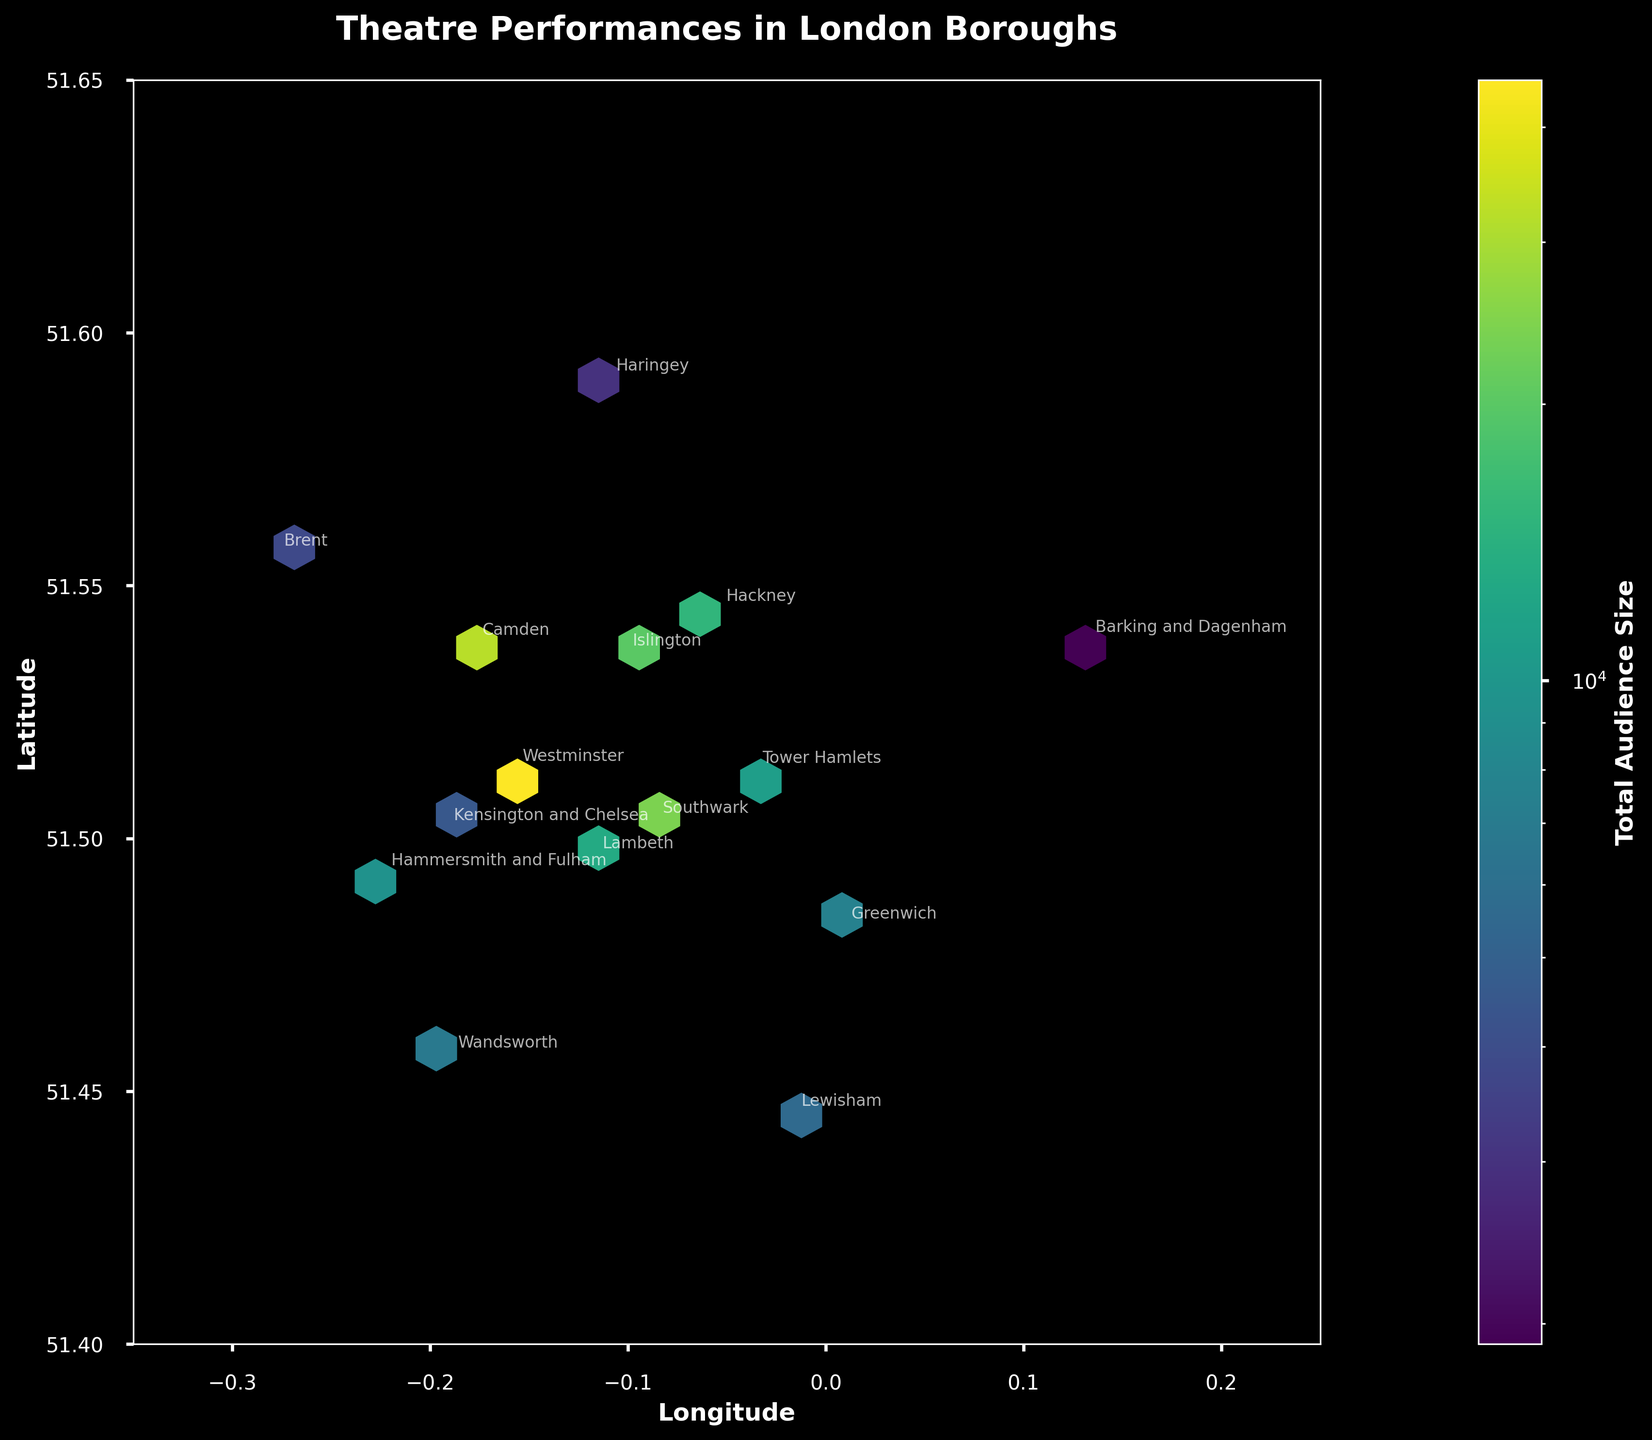how many total audience sizes are depicted on the color bar? The color bar indicates the summed audience sizes that correspond to the color intensity in the hexbin plot. It aggregates the total audience size for performances in specific geographic locations by different shades of color in a logarithmic scale.
Answer: Sum of audience sizes What's the total audience size for Lambeth? Locate Lambeth on the plot and identify its coordinates. Check the color intensity in and around that location on the plot, which reflects the audience size aggregated over that area.
Answer: 13,000 Which borough has the highest concentration of audience sizes? Find the hexbin on the plot with the highest color intensity. The borough labels will help identify which borough it is.
Answer: Westminster Between Hackney and Camden, which borough has more performances? Compare the positions of Hackney and Camden on the plot. Notice the size and color intensity of the hexagon bins in each of these locations to determine the number of performances.
Answer: Camden How does the audience size of Southwark compare to that of Islington? Locate Southwark and Islington on the plot. Compare the color intensities in those areas, as higher intensities indicate larger audience sizes.
Answer: Southwark has a larger audience size What is the smallest total audience size depicted in any hexbin on the plot? Identify the color bar's lower end to determine the smallest total audience size shown on the plot. Then find the hexbin that matches this color intensity.
Answer: 1 Do boroughs closer to central London tend to have higher audiences sizes? Observe the hexbin plot to see if color intensities (indicating audience sizes) are generally higher near central London compared to outer boroughs.
Answer: Yes What is the latitude range covered by the plot? Check the vertical axis (latitude) for the minimum and maximum values displayed at the beginning and end of the axis.
Answer: 51.4 to 51.65 Which boroughs have fewer than 20 performances? Refer to the plot for boroughs with smaller hexagons. Identify the names annotated next to these hexagons to determine the boroughs with fewer than 20 performances.
Answer: Greenwich, Wandsworth, Lewisham, Kensington and Chelsea, Brent, Haringey, Barking and Dagenham 